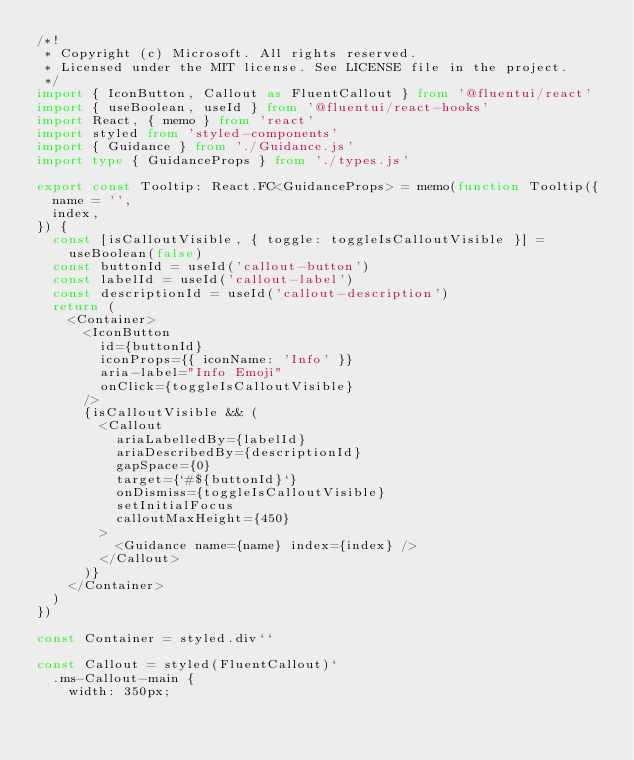Convert code to text. <code><loc_0><loc_0><loc_500><loc_500><_TypeScript_>/*!
 * Copyright (c) Microsoft. All rights reserved.
 * Licensed under the MIT license. See LICENSE file in the project.
 */
import { IconButton, Callout as FluentCallout } from '@fluentui/react'
import { useBoolean, useId } from '@fluentui/react-hooks'
import React, { memo } from 'react'
import styled from 'styled-components'
import { Guidance } from './Guidance.js'
import type { GuidanceProps } from './types.js'

export const Tooltip: React.FC<GuidanceProps> = memo(function Tooltip({
	name = '',
	index,
}) {
	const [isCalloutVisible, { toggle: toggleIsCalloutVisible }] =
		useBoolean(false)
	const buttonId = useId('callout-button')
	const labelId = useId('callout-label')
	const descriptionId = useId('callout-description')
	return (
		<Container>
			<IconButton
				id={buttonId}
				iconProps={{ iconName: 'Info' }}
				aria-label="Info Emoji"
				onClick={toggleIsCalloutVisible}
			/>
			{isCalloutVisible && (
				<Callout
					ariaLabelledBy={labelId}
					ariaDescribedBy={descriptionId}
					gapSpace={0}
					target={`#${buttonId}`}
					onDismiss={toggleIsCalloutVisible}
					setInitialFocus
					calloutMaxHeight={450}
				>
					<Guidance name={name} index={index} />
				</Callout>
			)}
		</Container>
	)
})

const Container = styled.div``

const Callout = styled(FluentCallout)`
	.ms-Callout-main {
		width: 350px;</code> 